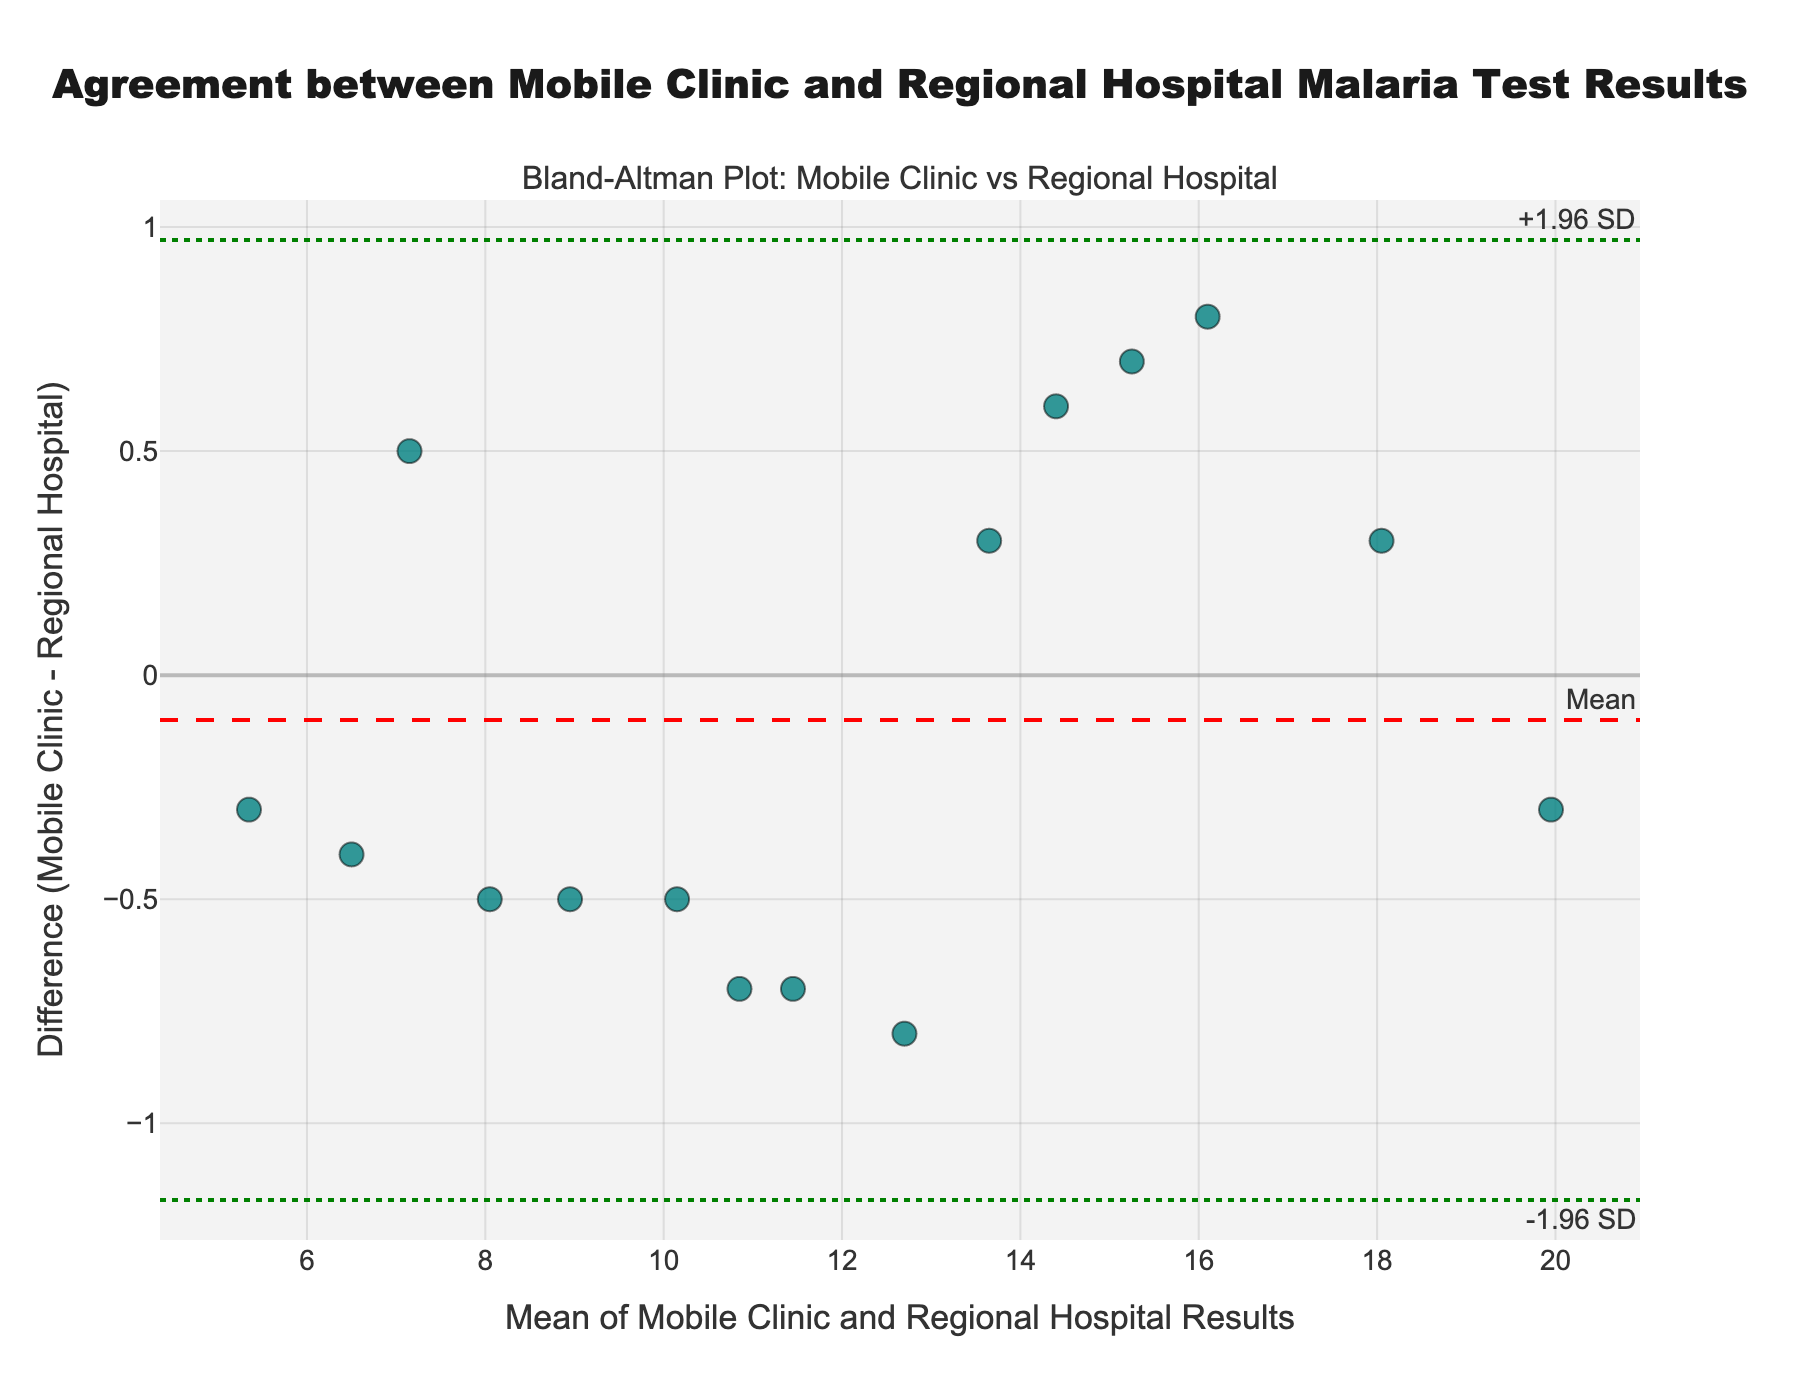What is the title of the plot? The title appears at the top center of the plot and it reads "Agreement between Mobile Clinic and Regional Hospital Malaria Test Results".
Answer: Agreement between Mobile Clinic and Regional Hospital Malaria Test Results What does the x-axis represent? The x-axis is labeled "Mean of Mobile Clinic and Regional Hospital Results", so it represents the average test result from both the mobile clinic and the regional hospital.
Answer: Mean of Mobile Clinic and Regional Hospital Results How many data points are there in the plot? By counting the number of markers in the scatter plot, we observe there are 15 data points.
Answer: 15 What is the mean difference between the Mobile Clinic and Regional Hospital results? A dashed red line labeled "Mean" indicates the average difference between the Mobile Clinic and Regional Hospital results.
Answer: Around 0 What meaning do the green dotted lines in the plot convey? The green dotted lines mark the upper and lower limits of agreement (LoA), which are mean difference ± 1.96 times the standard deviation of differences (± 1.96 SD).
Answer: Limits of agreement (+1.96 SD and -1.96 SD) What is the difference between the Mobile Clinic and Regional Hospital result for the patient with the lowest mean value? The patient with the lowest mean value has test results 5.2 from Mobile Clinic and 5.5 from Regional Hospital, appearing at the lowest x-value on the plot. The difference is 5.2 - 5.5 = -0.3.
Answer: -0.3 Is there any data point that falls exactly on the mean difference line? By examining the plot, we can see that there isn't any data point that aligns perfectly with the red dashed mean difference line.
Answer: No Do the majority of data points fall within the limits of agreement? Most data points are within the range marked by the green dotted lines, indicating that they fall within the limits of agreement.
Answer: Yes Which patient has the highest absolute difference between the Mobile Clinic and Regional Hospital results? We seek the largest vertical distance from the x-axis (0 difference). The data point close to an absolute difference of about 0.5 appears at (mean ~7.1, diff ~0.5), corresponding to the test results of Mobile Clinic 7.4 and Regional Hospital 6.9.
Answer: Patient P006 Is there any systematic bias observed between the Mobile Clinic and Regional Hospital test results? A systematic bias would imply consistently higher or lower results from one test site. The mean difference line is close to zero, suggesting no systematic bias.
Answer: No 